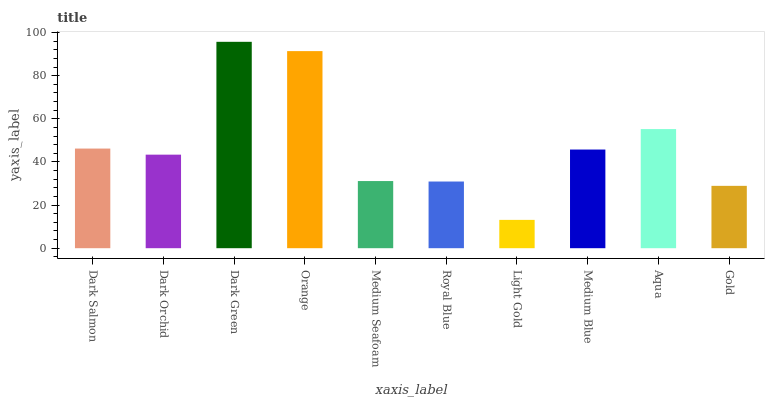Is Light Gold the minimum?
Answer yes or no. Yes. Is Dark Green the maximum?
Answer yes or no. Yes. Is Dark Orchid the minimum?
Answer yes or no. No. Is Dark Orchid the maximum?
Answer yes or no. No. Is Dark Salmon greater than Dark Orchid?
Answer yes or no. Yes. Is Dark Orchid less than Dark Salmon?
Answer yes or no. Yes. Is Dark Orchid greater than Dark Salmon?
Answer yes or no. No. Is Dark Salmon less than Dark Orchid?
Answer yes or no. No. Is Medium Blue the high median?
Answer yes or no. Yes. Is Dark Orchid the low median?
Answer yes or no. Yes. Is Dark Salmon the high median?
Answer yes or no. No. Is Medium Blue the low median?
Answer yes or no. No. 